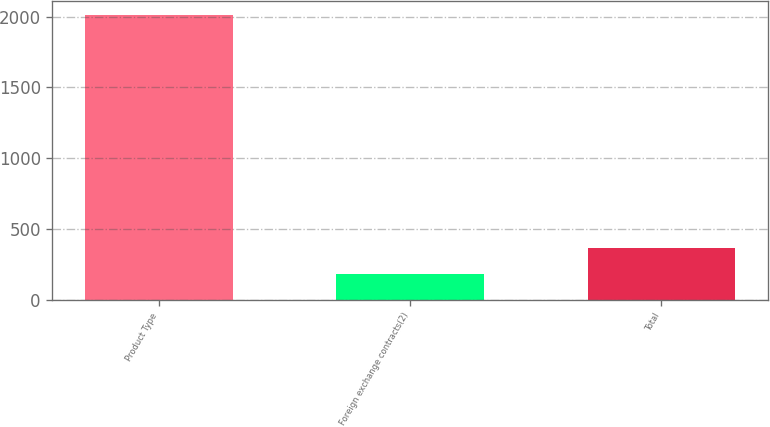Convert chart. <chart><loc_0><loc_0><loc_500><loc_500><bar_chart><fcel>Product Type<fcel>Foreign exchange contracts(2)<fcel>Total<nl><fcel>2011<fcel>180<fcel>363.1<nl></chart> 